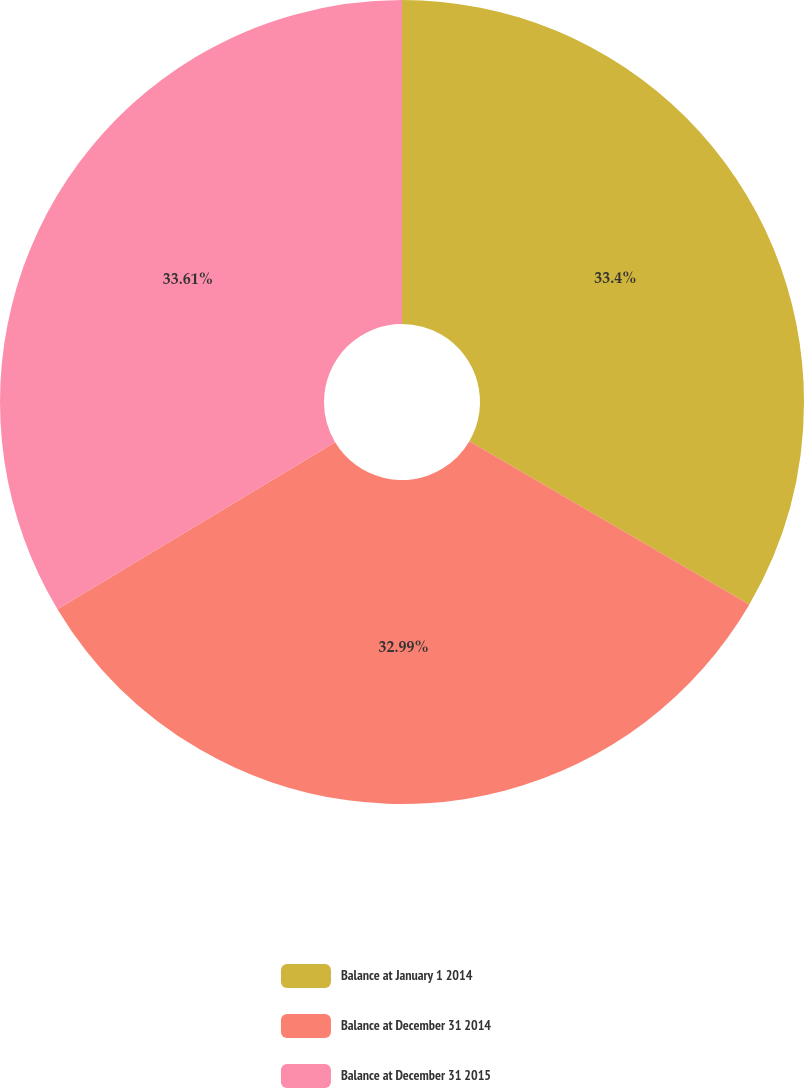Convert chart to OTSL. <chart><loc_0><loc_0><loc_500><loc_500><pie_chart><fcel>Balance at January 1 2014<fcel>Balance at December 31 2014<fcel>Balance at December 31 2015<nl><fcel>33.4%<fcel>32.99%<fcel>33.62%<nl></chart> 